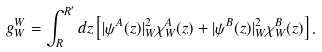<formula> <loc_0><loc_0><loc_500><loc_500>g ^ { W } _ { W } = \int _ { R } ^ { R ^ { \prime } } d z \left [ | \psi ^ { A } ( z ) | _ { W } ^ { 2 } \chi _ { W } ^ { A } ( z ) + | \psi ^ { B } ( z ) | _ { W } ^ { 2 } \chi _ { W } ^ { B } ( z ) \right ] .</formula> 